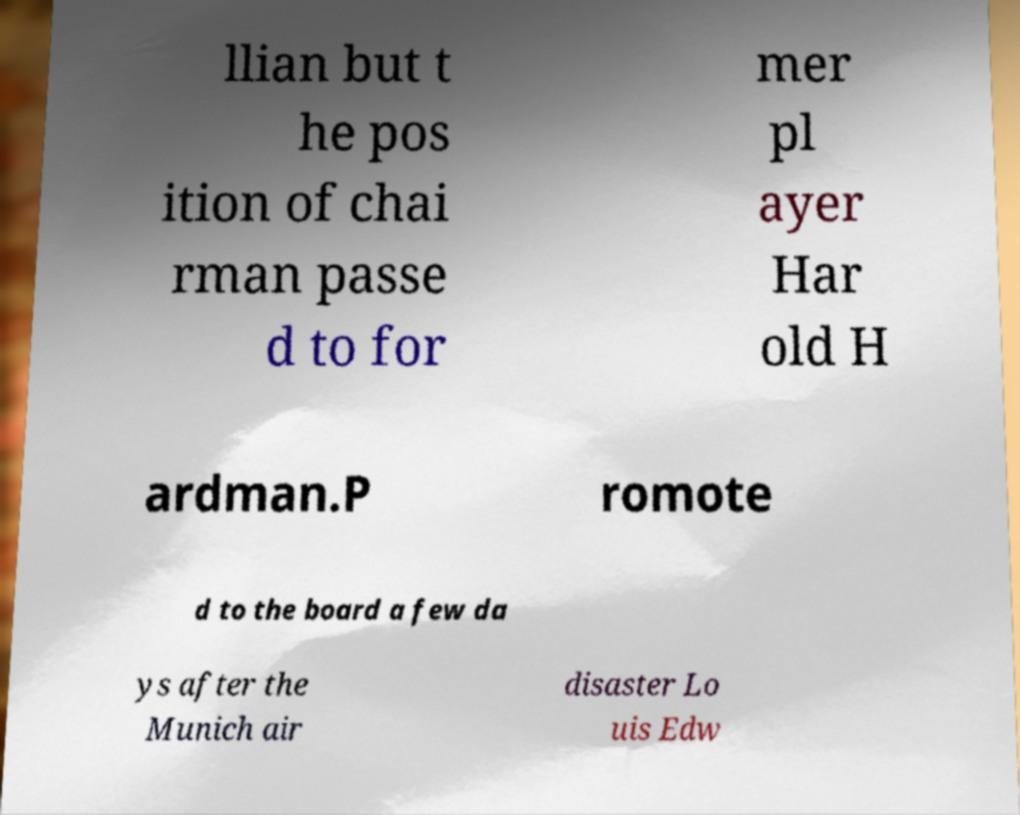Please identify and transcribe the text found in this image. llian but t he pos ition of chai rman passe d to for mer pl ayer Har old H ardman.P romote d to the board a few da ys after the Munich air disaster Lo uis Edw 